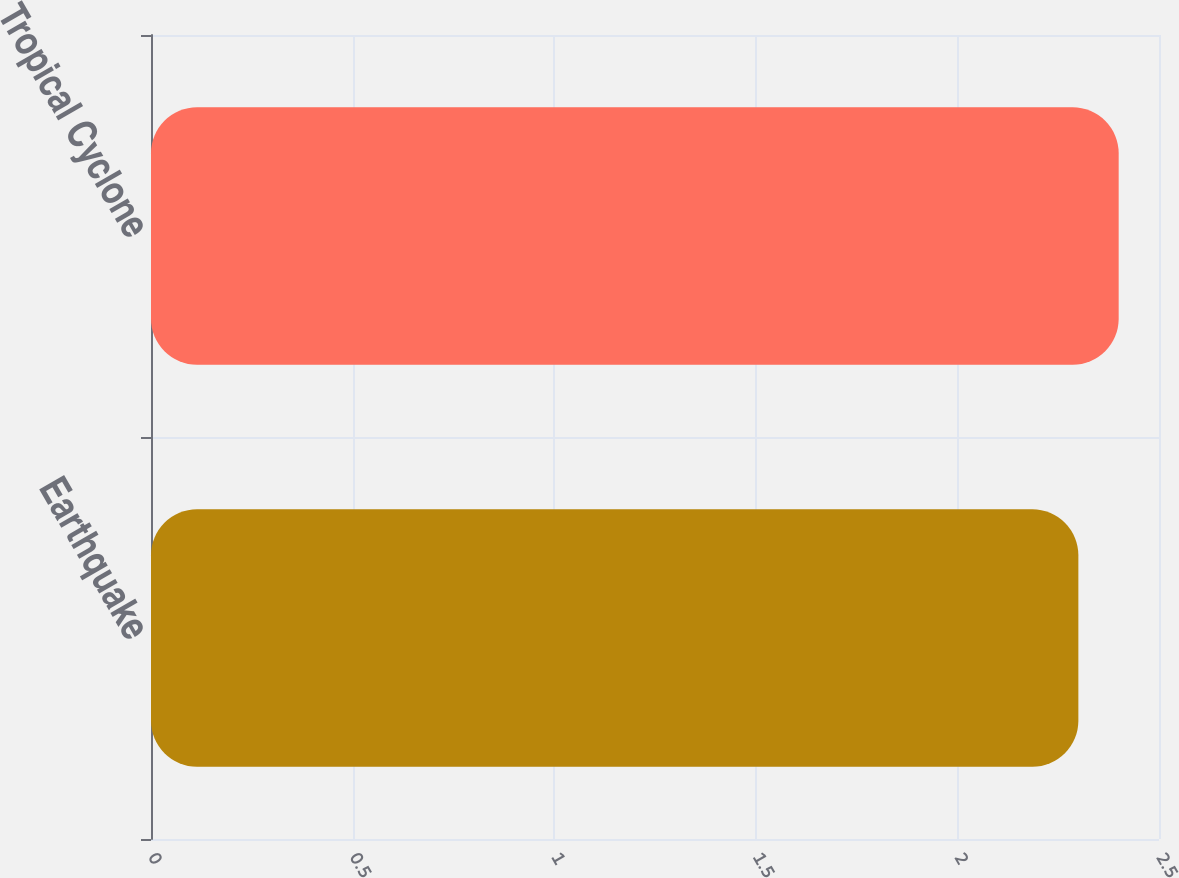<chart> <loc_0><loc_0><loc_500><loc_500><bar_chart><fcel>Earthquake<fcel>Tropical Cyclone<nl><fcel>2.3<fcel>2.4<nl></chart> 